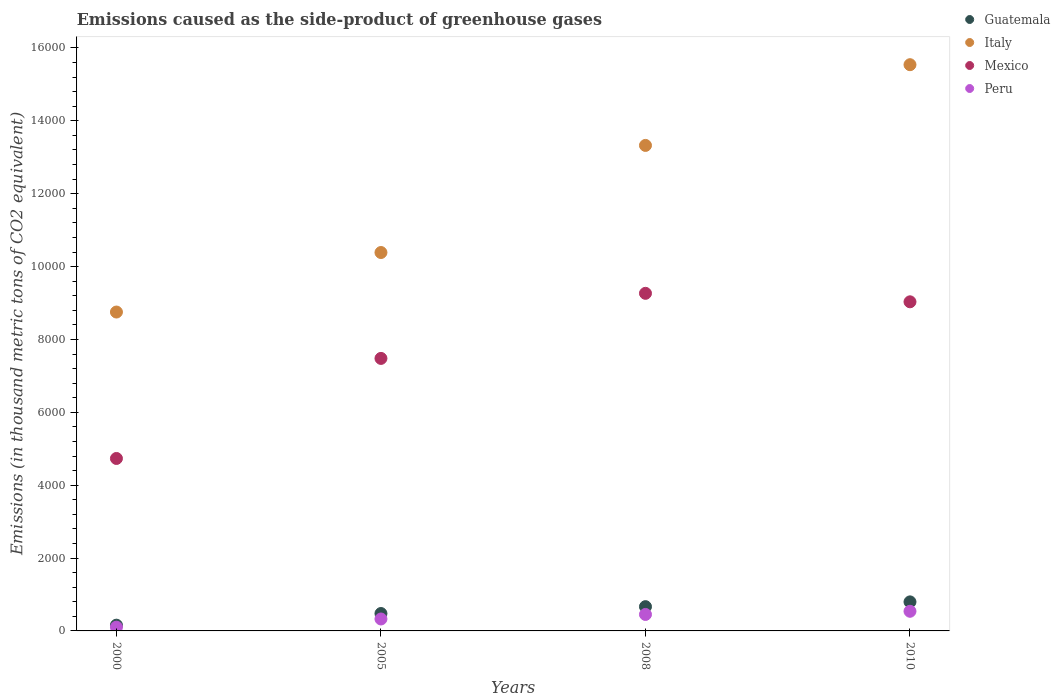What is the emissions caused as the side-product of greenhouse gases in Mexico in 2000?
Ensure brevity in your answer.  4733.2. Across all years, what is the maximum emissions caused as the side-product of greenhouse gases in Italy?
Your answer should be very brief. 1.55e+04. Across all years, what is the minimum emissions caused as the side-product of greenhouse gases in Guatemala?
Your answer should be very brief. 157.6. In which year was the emissions caused as the side-product of greenhouse gases in Mexico minimum?
Make the answer very short. 2000. What is the total emissions caused as the side-product of greenhouse gases in Mexico in the graph?
Your response must be concise. 3.05e+04. What is the difference between the emissions caused as the side-product of greenhouse gases in Mexico in 2000 and that in 2008?
Provide a short and direct response. -4532.6. What is the difference between the emissions caused as the side-product of greenhouse gases in Italy in 2000 and the emissions caused as the side-product of greenhouse gases in Peru in 2005?
Provide a succinct answer. 8424.7. What is the average emissions caused as the side-product of greenhouse gases in Guatemala per year?
Your answer should be very brief. 524.55. In the year 2008, what is the difference between the emissions caused as the side-product of greenhouse gases in Mexico and emissions caused as the side-product of greenhouse gases in Peru?
Make the answer very short. 8813.8. In how many years, is the emissions caused as the side-product of greenhouse gases in Peru greater than 12800 thousand metric tons?
Give a very brief answer. 0. What is the ratio of the emissions caused as the side-product of greenhouse gases in Peru in 2000 to that in 2008?
Offer a very short reply. 0.23. Is the difference between the emissions caused as the side-product of greenhouse gases in Mexico in 2005 and 2008 greater than the difference between the emissions caused as the side-product of greenhouse gases in Peru in 2005 and 2008?
Keep it short and to the point. No. What is the difference between the highest and the second highest emissions caused as the side-product of greenhouse gases in Guatemala?
Give a very brief answer. 131.2. What is the difference between the highest and the lowest emissions caused as the side-product of greenhouse gases in Mexico?
Your response must be concise. 4532.6. Is the sum of the emissions caused as the side-product of greenhouse gases in Mexico in 2000 and 2010 greater than the maximum emissions caused as the side-product of greenhouse gases in Guatemala across all years?
Your answer should be compact. Yes. Is it the case that in every year, the sum of the emissions caused as the side-product of greenhouse gases in Peru and emissions caused as the side-product of greenhouse gases in Mexico  is greater than the sum of emissions caused as the side-product of greenhouse gases in Guatemala and emissions caused as the side-product of greenhouse gases in Italy?
Offer a very short reply. Yes. Is it the case that in every year, the sum of the emissions caused as the side-product of greenhouse gases in Peru and emissions caused as the side-product of greenhouse gases in Guatemala  is greater than the emissions caused as the side-product of greenhouse gases in Mexico?
Provide a short and direct response. No. Does the emissions caused as the side-product of greenhouse gases in Guatemala monotonically increase over the years?
Give a very brief answer. Yes. Is the emissions caused as the side-product of greenhouse gases in Mexico strictly greater than the emissions caused as the side-product of greenhouse gases in Italy over the years?
Offer a terse response. No. How many dotlines are there?
Offer a terse response. 4. Are the values on the major ticks of Y-axis written in scientific E-notation?
Your answer should be very brief. No. Does the graph contain any zero values?
Your response must be concise. No. How many legend labels are there?
Your answer should be very brief. 4. What is the title of the graph?
Make the answer very short. Emissions caused as the side-product of greenhouse gases. What is the label or title of the Y-axis?
Your answer should be compact. Emissions (in thousand metric tons of CO2 equivalent). What is the Emissions (in thousand metric tons of CO2 equivalent) in Guatemala in 2000?
Ensure brevity in your answer.  157.6. What is the Emissions (in thousand metric tons of CO2 equivalent) of Italy in 2000?
Keep it short and to the point. 8752.3. What is the Emissions (in thousand metric tons of CO2 equivalent) of Mexico in 2000?
Provide a short and direct response. 4733.2. What is the Emissions (in thousand metric tons of CO2 equivalent) of Peru in 2000?
Provide a short and direct response. 103.1. What is the Emissions (in thousand metric tons of CO2 equivalent) of Guatemala in 2005?
Keep it short and to the point. 477.8. What is the Emissions (in thousand metric tons of CO2 equivalent) in Italy in 2005?
Give a very brief answer. 1.04e+04. What is the Emissions (in thousand metric tons of CO2 equivalent) of Mexico in 2005?
Provide a short and direct response. 7479.5. What is the Emissions (in thousand metric tons of CO2 equivalent) of Peru in 2005?
Keep it short and to the point. 327.6. What is the Emissions (in thousand metric tons of CO2 equivalent) of Guatemala in 2008?
Offer a terse response. 665.8. What is the Emissions (in thousand metric tons of CO2 equivalent) in Italy in 2008?
Offer a very short reply. 1.33e+04. What is the Emissions (in thousand metric tons of CO2 equivalent) in Mexico in 2008?
Give a very brief answer. 9265.8. What is the Emissions (in thousand metric tons of CO2 equivalent) of Peru in 2008?
Ensure brevity in your answer.  452. What is the Emissions (in thousand metric tons of CO2 equivalent) in Guatemala in 2010?
Your response must be concise. 797. What is the Emissions (in thousand metric tons of CO2 equivalent) of Italy in 2010?
Give a very brief answer. 1.55e+04. What is the Emissions (in thousand metric tons of CO2 equivalent) in Mexico in 2010?
Offer a terse response. 9033. What is the Emissions (in thousand metric tons of CO2 equivalent) in Peru in 2010?
Provide a short and direct response. 539. Across all years, what is the maximum Emissions (in thousand metric tons of CO2 equivalent) in Guatemala?
Provide a succinct answer. 797. Across all years, what is the maximum Emissions (in thousand metric tons of CO2 equivalent) of Italy?
Make the answer very short. 1.55e+04. Across all years, what is the maximum Emissions (in thousand metric tons of CO2 equivalent) of Mexico?
Your answer should be very brief. 9265.8. Across all years, what is the maximum Emissions (in thousand metric tons of CO2 equivalent) of Peru?
Provide a succinct answer. 539. Across all years, what is the minimum Emissions (in thousand metric tons of CO2 equivalent) of Guatemala?
Give a very brief answer. 157.6. Across all years, what is the minimum Emissions (in thousand metric tons of CO2 equivalent) of Italy?
Your answer should be compact. 8752.3. Across all years, what is the minimum Emissions (in thousand metric tons of CO2 equivalent) of Mexico?
Give a very brief answer. 4733.2. Across all years, what is the minimum Emissions (in thousand metric tons of CO2 equivalent) in Peru?
Your answer should be compact. 103.1. What is the total Emissions (in thousand metric tons of CO2 equivalent) of Guatemala in the graph?
Provide a short and direct response. 2098.2. What is the total Emissions (in thousand metric tons of CO2 equivalent) of Italy in the graph?
Provide a short and direct response. 4.80e+04. What is the total Emissions (in thousand metric tons of CO2 equivalent) of Mexico in the graph?
Your answer should be very brief. 3.05e+04. What is the total Emissions (in thousand metric tons of CO2 equivalent) in Peru in the graph?
Provide a succinct answer. 1421.7. What is the difference between the Emissions (in thousand metric tons of CO2 equivalent) of Guatemala in 2000 and that in 2005?
Provide a succinct answer. -320.2. What is the difference between the Emissions (in thousand metric tons of CO2 equivalent) of Italy in 2000 and that in 2005?
Your answer should be very brief. -1633.7. What is the difference between the Emissions (in thousand metric tons of CO2 equivalent) of Mexico in 2000 and that in 2005?
Provide a succinct answer. -2746.3. What is the difference between the Emissions (in thousand metric tons of CO2 equivalent) of Peru in 2000 and that in 2005?
Provide a short and direct response. -224.5. What is the difference between the Emissions (in thousand metric tons of CO2 equivalent) of Guatemala in 2000 and that in 2008?
Provide a succinct answer. -508.2. What is the difference between the Emissions (in thousand metric tons of CO2 equivalent) in Italy in 2000 and that in 2008?
Give a very brief answer. -4573.1. What is the difference between the Emissions (in thousand metric tons of CO2 equivalent) in Mexico in 2000 and that in 2008?
Provide a short and direct response. -4532.6. What is the difference between the Emissions (in thousand metric tons of CO2 equivalent) of Peru in 2000 and that in 2008?
Ensure brevity in your answer.  -348.9. What is the difference between the Emissions (in thousand metric tons of CO2 equivalent) in Guatemala in 2000 and that in 2010?
Offer a very short reply. -639.4. What is the difference between the Emissions (in thousand metric tons of CO2 equivalent) in Italy in 2000 and that in 2010?
Offer a very short reply. -6788.7. What is the difference between the Emissions (in thousand metric tons of CO2 equivalent) in Mexico in 2000 and that in 2010?
Offer a terse response. -4299.8. What is the difference between the Emissions (in thousand metric tons of CO2 equivalent) of Peru in 2000 and that in 2010?
Keep it short and to the point. -435.9. What is the difference between the Emissions (in thousand metric tons of CO2 equivalent) in Guatemala in 2005 and that in 2008?
Your response must be concise. -188. What is the difference between the Emissions (in thousand metric tons of CO2 equivalent) of Italy in 2005 and that in 2008?
Your response must be concise. -2939.4. What is the difference between the Emissions (in thousand metric tons of CO2 equivalent) in Mexico in 2005 and that in 2008?
Make the answer very short. -1786.3. What is the difference between the Emissions (in thousand metric tons of CO2 equivalent) of Peru in 2005 and that in 2008?
Offer a terse response. -124.4. What is the difference between the Emissions (in thousand metric tons of CO2 equivalent) in Guatemala in 2005 and that in 2010?
Make the answer very short. -319.2. What is the difference between the Emissions (in thousand metric tons of CO2 equivalent) of Italy in 2005 and that in 2010?
Keep it short and to the point. -5155. What is the difference between the Emissions (in thousand metric tons of CO2 equivalent) of Mexico in 2005 and that in 2010?
Offer a terse response. -1553.5. What is the difference between the Emissions (in thousand metric tons of CO2 equivalent) in Peru in 2005 and that in 2010?
Provide a short and direct response. -211.4. What is the difference between the Emissions (in thousand metric tons of CO2 equivalent) of Guatemala in 2008 and that in 2010?
Make the answer very short. -131.2. What is the difference between the Emissions (in thousand metric tons of CO2 equivalent) of Italy in 2008 and that in 2010?
Ensure brevity in your answer.  -2215.6. What is the difference between the Emissions (in thousand metric tons of CO2 equivalent) of Mexico in 2008 and that in 2010?
Offer a very short reply. 232.8. What is the difference between the Emissions (in thousand metric tons of CO2 equivalent) of Peru in 2008 and that in 2010?
Provide a succinct answer. -87. What is the difference between the Emissions (in thousand metric tons of CO2 equivalent) in Guatemala in 2000 and the Emissions (in thousand metric tons of CO2 equivalent) in Italy in 2005?
Your response must be concise. -1.02e+04. What is the difference between the Emissions (in thousand metric tons of CO2 equivalent) of Guatemala in 2000 and the Emissions (in thousand metric tons of CO2 equivalent) of Mexico in 2005?
Provide a short and direct response. -7321.9. What is the difference between the Emissions (in thousand metric tons of CO2 equivalent) of Guatemala in 2000 and the Emissions (in thousand metric tons of CO2 equivalent) of Peru in 2005?
Give a very brief answer. -170. What is the difference between the Emissions (in thousand metric tons of CO2 equivalent) of Italy in 2000 and the Emissions (in thousand metric tons of CO2 equivalent) of Mexico in 2005?
Give a very brief answer. 1272.8. What is the difference between the Emissions (in thousand metric tons of CO2 equivalent) of Italy in 2000 and the Emissions (in thousand metric tons of CO2 equivalent) of Peru in 2005?
Offer a terse response. 8424.7. What is the difference between the Emissions (in thousand metric tons of CO2 equivalent) of Mexico in 2000 and the Emissions (in thousand metric tons of CO2 equivalent) of Peru in 2005?
Offer a terse response. 4405.6. What is the difference between the Emissions (in thousand metric tons of CO2 equivalent) in Guatemala in 2000 and the Emissions (in thousand metric tons of CO2 equivalent) in Italy in 2008?
Provide a short and direct response. -1.32e+04. What is the difference between the Emissions (in thousand metric tons of CO2 equivalent) in Guatemala in 2000 and the Emissions (in thousand metric tons of CO2 equivalent) in Mexico in 2008?
Give a very brief answer. -9108.2. What is the difference between the Emissions (in thousand metric tons of CO2 equivalent) in Guatemala in 2000 and the Emissions (in thousand metric tons of CO2 equivalent) in Peru in 2008?
Provide a succinct answer. -294.4. What is the difference between the Emissions (in thousand metric tons of CO2 equivalent) in Italy in 2000 and the Emissions (in thousand metric tons of CO2 equivalent) in Mexico in 2008?
Give a very brief answer. -513.5. What is the difference between the Emissions (in thousand metric tons of CO2 equivalent) of Italy in 2000 and the Emissions (in thousand metric tons of CO2 equivalent) of Peru in 2008?
Ensure brevity in your answer.  8300.3. What is the difference between the Emissions (in thousand metric tons of CO2 equivalent) of Mexico in 2000 and the Emissions (in thousand metric tons of CO2 equivalent) of Peru in 2008?
Your answer should be compact. 4281.2. What is the difference between the Emissions (in thousand metric tons of CO2 equivalent) in Guatemala in 2000 and the Emissions (in thousand metric tons of CO2 equivalent) in Italy in 2010?
Your answer should be very brief. -1.54e+04. What is the difference between the Emissions (in thousand metric tons of CO2 equivalent) in Guatemala in 2000 and the Emissions (in thousand metric tons of CO2 equivalent) in Mexico in 2010?
Make the answer very short. -8875.4. What is the difference between the Emissions (in thousand metric tons of CO2 equivalent) in Guatemala in 2000 and the Emissions (in thousand metric tons of CO2 equivalent) in Peru in 2010?
Provide a succinct answer. -381.4. What is the difference between the Emissions (in thousand metric tons of CO2 equivalent) in Italy in 2000 and the Emissions (in thousand metric tons of CO2 equivalent) in Mexico in 2010?
Offer a very short reply. -280.7. What is the difference between the Emissions (in thousand metric tons of CO2 equivalent) of Italy in 2000 and the Emissions (in thousand metric tons of CO2 equivalent) of Peru in 2010?
Provide a succinct answer. 8213.3. What is the difference between the Emissions (in thousand metric tons of CO2 equivalent) in Mexico in 2000 and the Emissions (in thousand metric tons of CO2 equivalent) in Peru in 2010?
Your answer should be compact. 4194.2. What is the difference between the Emissions (in thousand metric tons of CO2 equivalent) in Guatemala in 2005 and the Emissions (in thousand metric tons of CO2 equivalent) in Italy in 2008?
Your answer should be very brief. -1.28e+04. What is the difference between the Emissions (in thousand metric tons of CO2 equivalent) in Guatemala in 2005 and the Emissions (in thousand metric tons of CO2 equivalent) in Mexico in 2008?
Offer a very short reply. -8788. What is the difference between the Emissions (in thousand metric tons of CO2 equivalent) of Guatemala in 2005 and the Emissions (in thousand metric tons of CO2 equivalent) of Peru in 2008?
Your response must be concise. 25.8. What is the difference between the Emissions (in thousand metric tons of CO2 equivalent) of Italy in 2005 and the Emissions (in thousand metric tons of CO2 equivalent) of Mexico in 2008?
Your response must be concise. 1120.2. What is the difference between the Emissions (in thousand metric tons of CO2 equivalent) of Italy in 2005 and the Emissions (in thousand metric tons of CO2 equivalent) of Peru in 2008?
Give a very brief answer. 9934. What is the difference between the Emissions (in thousand metric tons of CO2 equivalent) of Mexico in 2005 and the Emissions (in thousand metric tons of CO2 equivalent) of Peru in 2008?
Offer a terse response. 7027.5. What is the difference between the Emissions (in thousand metric tons of CO2 equivalent) in Guatemala in 2005 and the Emissions (in thousand metric tons of CO2 equivalent) in Italy in 2010?
Offer a very short reply. -1.51e+04. What is the difference between the Emissions (in thousand metric tons of CO2 equivalent) in Guatemala in 2005 and the Emissions (in thousand metric tons of CO2 equivalent) in Mexico in 2010?
Your answer should be compact. -8555.2. What is the difference between the Emissions (in thousand metric tons of CO2 equivalent) in Guatemala in 2005 and the Emissions (in thousand metric tons of CO2 equivalent) in Peru in 2010?
Keep it short and to the point. -61.2. What is the difference between the Emissions (in thousand metric tons of CO2 equivalent) in Italy in 2005 and the Emissions (in thousand metric tons of CO2 equivalent) in Mexico in 2010?
Ensure brevity in your answer.  1353. What is the difference between the Emissions (in thousand metric tons of CO2 equivalent) of Italy in 2005 and the Emissions (in thousand metric tons of CO2 equivalent) of Peru in 2010?
Give a very brief answer. 9847. What is the difference between the Emissions (in thousand metric tons of CO2 equivalent) in Mexico in 2005 and the Emissions (in thousand metric tons of CO2 equivalent) in Peru in 2010?
Ensure brevity in your answer.  6940.5. What is the difference between the Emissions (in thousand metric tons of CO2 equivalent) in Guatemala in 2008 and the Emissions (in thousand metric tons of CO2 equivalent) in Italy in 2010?
Provide a succinct answer. -1.49e+04. What is the difference between the Emissions (in thousand metric tons of CO2 equivalent) of Guatemala in 2008 and the Emissions (in thousand metric tons of CO2 equivalent) of Mexico in 2010?
Your response must be concise. -8367.2. What is the difference between the Emissions (in thousand metric tons of CO2 equivalent) of Guatemala in 2008 and the Emissions (in thousand metric tons of CO2 equivalent) of Peru in 2010?
Offer a terse response. 126.8. What is the difference between the Emissions (in thousand metric tons of CO2 equivalent) in Italy in 2008 and the Emissions (in thousand metric tons of CO2 equivalent) in Mexico in 2010?
Make the answer very short. 4292.4. What is the difference between the Emissions (in thousand metric tons of CO2 equivalent) in Italy in 2008 and the Emissions (in thousand metric tons of CO2 equivalent) in Peru in 2010?
Keep it short and to the point. 1.28e+04. What is the difference between the Emissions (in thousand metric tons of CO2 equivalent) in Mexico in 2008 and the Emissions (in thousand metric tons of CO2 equivalent) in Peru in 2010?
Your answer should be compact. 8726.8. What is the average Emissions (in thousand metric tons of CO2 equivalent) of Guatemala per year?
Offer a terse response. 524.55. What is the average Emissions (in thousand metric tons of CO2 equivalent) in Italy per year?
Offer a very short reply. 1.20e+04. What is the average Emissions (in thousand metric tons of CO2 equivalent) of Mexico per year?
Make the answer very short. 7627.88. What is the average Emissions (in thousand metric tons of CO2 equivalent) in Peru per year?
Keep it short and to the point. 355.43. In the year 2000, what is the difference between the Emissions (in thousand metric tons of CO2 equivalent) in Guatemala and Emissions (in thousand metric tons of CO2 equivalent) in Italy?
Your answer should be compact. -8594.7. In the year 2000, what is the difference between the Emissions (in thousand metric tons of CO2 equivalent) of Guatemala and Emissions (in thousand metric tons of CO2 equivalent) of Mexico?
Give a very brief answer. -4575.6. In the year 2000, what is the difference between the Emissions (in thousand metric tons of CO2 equivalent) of Guatemala and Emissions (in thousand metric tons of CO2 equivalent) of Peru?
Make the answer very short. 54.5. In the year 2000, what is the difference between the Emissions (in thousand metric tons of CO2 equivalent) in Italy and Emissions (in thousand metric tons of CO2 equivalent) in Mexico?
Provide a succinct answer. 4019.1. In the year 2000, what is the difference between the Emissions (in thousand metric tons of CO2 equivalent) in Italy and Emissions (in thousand metric tons of CO2 equivalent) in Peru?
Provide a short and direct response. 8649.2. In the year 2000, what is the difference between the Emissions (in thousand metric tons of CO2 equivalent) in Mexico and Emissions (in thousand metric tons of CO2 equivalent) in Peru?
Your response must be concise. 4630.1. In the year 2005, what is the difference between the Emissions (in thousand metric tons of CO2 equivalent) of Guatemala and Emissions (in thousand metric tons of CO2 equivalent) of Italy?
Offer a terse response. -9908.2. In the year 2005, what is the difference between the Emissions (in thousand metric tons of CO2 equivalent) of Guatemala and Emissions (in thousand metric tons of CO2 equivalent) of Mexico?
Make the answer very short. -7001.7. In the year 2005, what is the difference between the Emissions (in thousand metric tons of CO2 equivalent) in Guatemala and Emissions (in thousand metric tons of CO2 equivalent) in Peru?
Make the answer very short. 150.2. In the year 2005, what is the difference between the Emissions (in thousand metric tons of CO2 equivalent) in Italy and Emissions (in thousand metric tons of CO2 equivalent) in Mexico?
Make the answer very short. 2906.5. In the year 2005, what is the difference between the Emissions (in thousand metric tons of CO2 equivalent) in Italy and Emissions (in thousand metric tons of CO2 equivalent) in Peru?
Ensure brevity in your answer.  1.01e+04. In the year 2005, what is the difference between the Emissions (in thousand metric tons of CO2 equivalent) in Mexico and Emissions (in thousand metric tons of CO2 equivalent) in Peru?
Offer a terse response. 7151.9. In the year 2008, what is the difference between the Emissions (in thousand metric tons of CO2 equivalent) of Guatemala and Emissions (in thousand metric tons of CO2 equivalent) of Italy?
Your answer should be very brief. -1.27e+04. In the year 2008, what is the difference between the Emissions (in thousand metric tons of CO2 equivalent) of Guatemala and Emissions (in thousand metric tons of CO2 equivalent) of Mexico?
Ensure brevity in your answer.  -8600. In the year 2008, what is the difference between the Emissions (in thousand metric tons of CO2 equivalent) in Guatemala and Emissions (in thousand metric tons of CO2 equivalent) in Peru?
Offer a terse response. 213.8. In the year 2008, what is the difference between the Emissions (in thousand metric tons of CO2 equivalent) in Italy and Emissions (in thousand metric tons of CO2 equivalent) in Mexico?
Your response must be concise. 4059.6. In the year 2008, what is the difference between the Emissions (in thousand metric tons of CO2 equivalent) in Italy and Emissions (in thousand metric tons of CO2 equivalent) in Peru?
Offer a terse response. 1.29e+04. In the year 2008, what is the difference between the Emissions (in thousand metric tons of CO2 equivalent) in Mexico and Emissions (in thousand metric tons of CO2 equivalent) in Peru?
Give a very brief answer. 8813.8. In the year 2010, what is the difference between the Emissions (in thousand metric tons of CO2 equivalent) in Guatemala and Emissions (in thousand metric tons of CO2 equivalent) in Italy?
Make the answer very short. -1.47e+04. In the year 2010, what is the difference between the Emissions (in thousand metric tons of CO2 equivalent) of Guatemala and Emissions (in thousand metric tons of CO2 equivalent) of Mexico?
Provide a short and direct response. -8236. In the year 2010, what is the difference between the Emissions (in thousand metric tons of CO2 equivalent) in Guatemala and Emissions (in thousand metric tons of CO2 equivalent) in Peru?
Your answer should be compact. 258. In the year 2010, what is the difference between the Emissions (in thousand metric tons of CO2 equivalent) of Italy and Emissions (in thousand metric tons of CO2 equivalent) of Mexico?
Provide a succinct answer. 6508. In the year 2010, what is the difference between the Emissions (in thousand metric tons of CO2 equivalent) in Italy and Emissions (in thousand metric tons of CO2 equivalent) in Peru?
Offer a very short reply. 1.50e+04. In the year 2010, what is the difference between the Emissions (in thousand metric tons of CO2 equivalent) in Mexico and Emissions (in thousand metric tons of CO2 equivalent) in Peru?
Provide a succinct answer. 8494. What is the ratio of the Emissions (in thousand metric tons of CO2 equivalent) of Guatemala in 2000 to that in 2005?
Offer a terse response. 0.33. What is the ratio of the Emissions (in thousand metric tons of CO2 equivalent) in Italy in 2000 to that in 2005?
Your answer should be very brief. 0.84. What is the ratio of the Emissions (in thousand metric tons of CO2 equivalent) of Mexico in 2000 to that in 2005?
Make the answer very short. 0.63. What is the ratio of the Emissions (in thousand metric tons of CO2 equivalent) of Peru in 2000 to that in 2005?
Offer a terse response. 0.31. What is the ratio of the Emissions (in thousand metric tons of CO2 equivalent) in Guatemala in 2000 to that in 2008?
Make the answer very short. 0.24. What is the ratio of the Emissions (in thousand metric tons of CO2 equivalent) of Italy in 2000 to that in 2008?
Your answer should be very brief. 0.66. What is the ratio of the Emissions (in thousand metric tons of CO2 equivalent) in Mexico in 2000 to that in 2008?
Provide a succinct answer. 0.51. What is the ratio of the Emissions (in thousand metric tons of CO2 equivalent) of Peru in 2000 to that in 2008?
Offer a very short reply. 0.23. What is the ratio of the Emissions (in thousand metric tons of CO2 equivalent) in Guatemala in 2000 to that in 2010?
Offer a very short reply. 0.2. What is the ratio of the Emissions (in thousand metric tons of CO2 equivalent) in Italy in 2000 to that in 2010?
Provide a short and direct response. 0.56. What is the ratio of the Emissions (in thousand metric tons of CO2 equivalent) in Mexico in 2000 to that in 2010?
Your response must be concise. 0.52. What is the ratio of the Emissions (in thousand metric tons of CO2 equivalent) of Peru in 2000 to that in 2010?
Provide a succinct answer. 0.19. What is the ratio of the Emissions (in thousand metric tons of CO2 equivalent) of Guatemala in 2005 to that in 2008?
Ensure brevity in your answer.  0.72. What is the ratio of the Emissions (in thousand metric tons of CO2 equivalent) in Italy in 2005 to that in 2008?
Provide a succinct answer. 0.78. What is the ratio of the Emissions (in thousand metric tons of CO2 equivalent) in Mexico in 2005 to that in 2008?
Provide a short and direct response. 0.81. What is the ratio of the Emissions (in thousand metric tons of CO2 equivalent) in Peru in 2005 to that in 2008?
Offer a very short reply. 0.72. What is the ratio of the Emissions (in thousand metric tons of CO2 equivalent) in Guatemala in 2005 to that in 2010?
Your response must be concise. 0.6. What is the ratio of the Emissions (in thousand metric tons of CO2 equivalent) in Italy in 2005 to that in 2010?
Provide a succinct answer. 0.67. What is the ratio of the Emissions (in thousand metric tons of CO2 equivalent) of Mexico in 2005 to that in 2010?
Provide a succinct answer. 0.83. What is the ratio of the Emissions (in thousand metric tons of CO2 equivalent) of Peru in 2005 to that in 2010?
Your response must be concise. 0.61. What is the ratio of the Emissions (in thousand metric tons of CO2 equivalent) of Guatemala in 2008 to that in 2010?
Keep it short and to the point. 0.84. What is the ratio of the Emissions (in thousand metric tons of CO2 equivalent) of Italy in 2008 to that in 2010?
Give a very brief answer. 0.86. What is the ratio of the Emissions (in thousand metric tons of CO2 equivalent) of Mexico in 2008 to that in 2010?
Your response must be concise. 1.03. What is the ratio of the Emissions (in thousand metric tons of CO2 equivalent) of Peru in 2008 to that in 2010?
Your answer should be very brief. 0.84. What is the difference between the highest and the second highest Emissions (in thousand metric tons of CO2 equivalent) of Guatemala?
Your answer should be compact. 131.2. What is the difference between the highest and the second highest Emissions (in thousand metric tons of CO2 equivalent) in Italy?
Ensure brevity in your answer.  2215.6. What is the difference between the highest and the second highest Emissions (in thousand metric tons of CO2 equivalent) of Mexico?
Offer a very short reply. 232.8. What is the difference between the highest and the lowest Emissions (in thousand metric tons of CO2 equivalent) in Guatemala?
Your answer should be very brief. 639.4. What is the difference between the highest and the lowest Emissions (in thousand metric tons of CO2 equivalent) in Italy?
Offer a terse response. 6788.7. What is the difference between the highest and the lowest Emissions (in thousand metric tons of CO2 equivalent) of Mexico?
Your answer should be compact. 4532.6. What is the difference between the highest and the lowest Emissions (in thousand metric tons of CO2 equivalent) in Peru?
Your response must be concise. 435.9. 